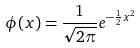Convert formula to latex. <formula><loc_0><loc_0><loc_500><loc_500>\phi ( x ) = \frac { 1 } { \sqrt { 2 \pi } } e ^ { - \frac { 1 } { 2 } x ^ { 2 } }</formula> 